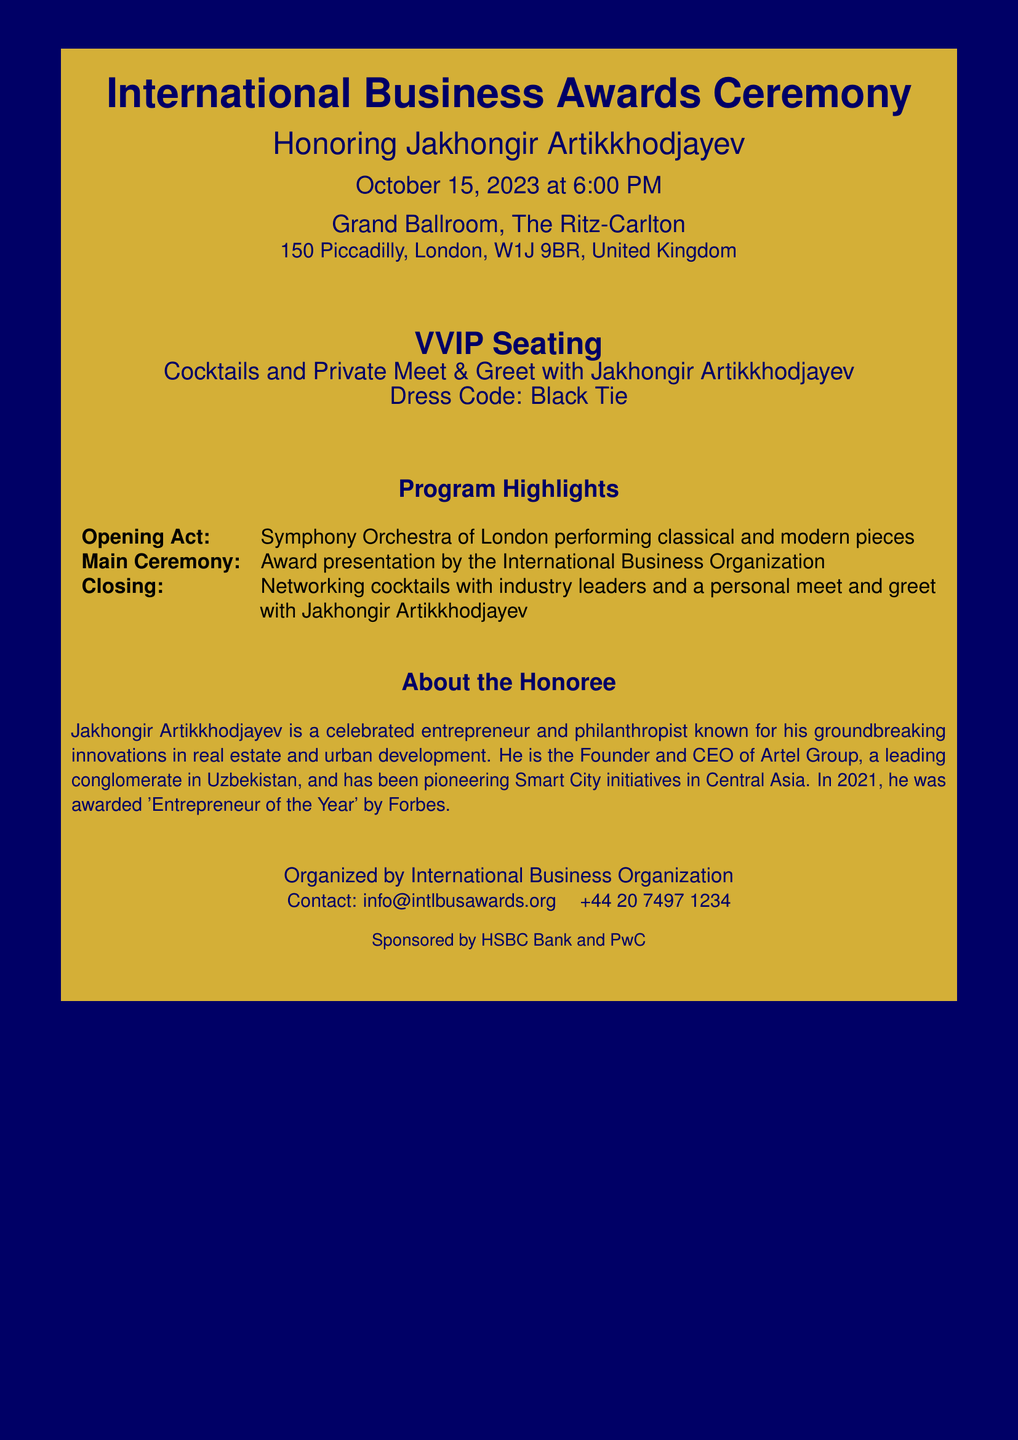What is the date of the ceremony? The date is clearly stated in the document as October 15, 2023.
Answer: October 15, 2023 Where is the ceremony taking place? The location is specified in the document as Grand Ballroom, The Ritz-Carlton.
Answer: Grand Ballroom, The Ritz-Carlton Who is being honored at the event? The document mentions Jakhongir Artikkhodjayev as the honoree.
Answer: Jakhongir Artikkhodjayev What type of seating is provided for guests? The document explicitly states that VVIP seating is provided.
Answer: VVIP Seating What is the dress code for the event? The dress code is outlined in the document as Black Tie.
Answer: Black Tie What is one of the highlights of the program? The document lists the award presentation by the International Business Organization as a highlight.
Answer: Award presentation by the International Business Organization Who is the founder and CEO mentioned in the document? The document refers to Jakhongir Artikkhodjayev as the founder and CEO of Artel Group.
Answer: Jakhongir Artikkhodjayev Which organizations sponsored the event? The sponsors listed in the document are HSBC Bank and PwC.
Answer: HSBC Bank and PwC What will attendees have the opportunity to do after the main ceremony? The document states that attendees can enjoy networking cocktails.
Answer: Networking cocktails 